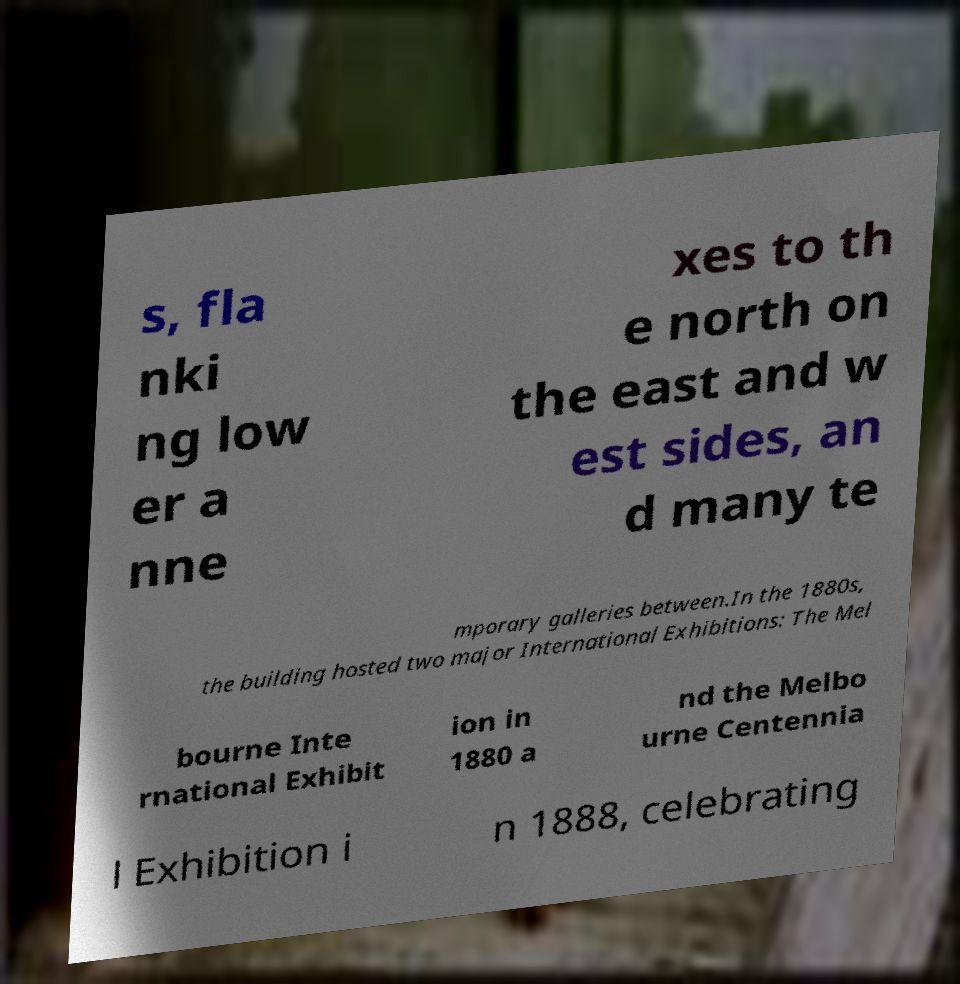For documentation purposes, I need the text within this image transcribed. Could you provide that? s, fla nki ng low er a nne xes to th e north on the east and w est sides, an d many te mporary galleries between.In the 1880s, the building hosted two major International Exhibitions: The Mel bourne Inte rnational Exhibit ion in 1880 a nd the Melbo urne Centennia l Exhibition i n 1888, celebrating 